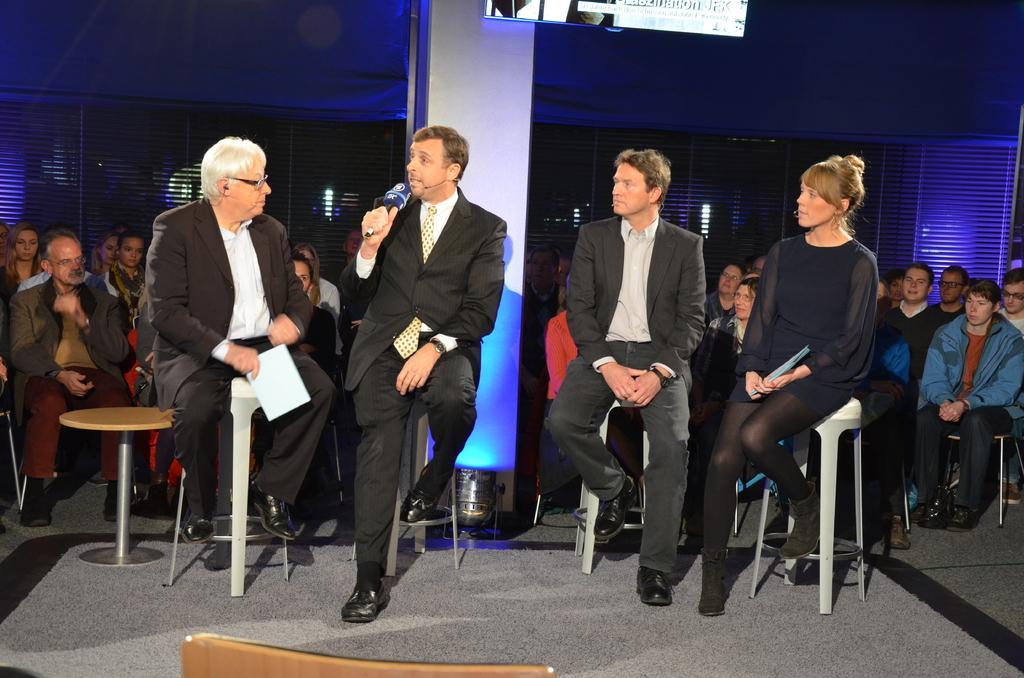Could you give a brief overview of what you see in this image? This picture describes about group of people, they are all seated on the chair one person is holding a microphone in his hand, another person is holding a paper, on top of them you can find a monitor. 